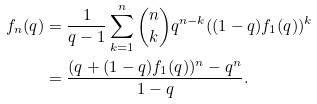Convert formula to latex. <formula><loc_0><loc_0><loc_500><loc_500>f _ { n } ( q ) & = \frac { 1 } { q - 1 } \sum _ { k = 1 } ^ { n } { n \choose k } q ^ { n - k } ( ( 1 - q ) f _ { 1 } ( q ) ) ^ { k } \\ & = \frac { ( q + ( 1 - q ) f _ { 1 } ( q ) ) ^ { n } - q ^ { n } } { 1 - q } .</formula> 